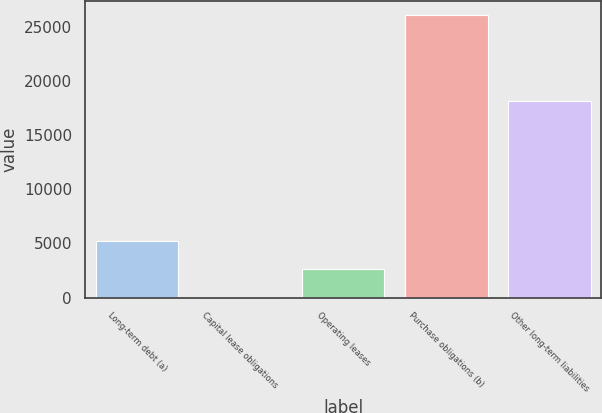<chart> <loc_0><loc_0><loc_500><loc_500><bar_chart><fcel>Long-term debt (a)<fcel>Capital lease obligations<fcel>Operating leases<fcel>Purchase obligations (b)<fcel>Other long-term liabilities<nl><fcel>5255<fcel>30<fcel>2642.5<fcel>26155<fcel>18169<nl></chart> 